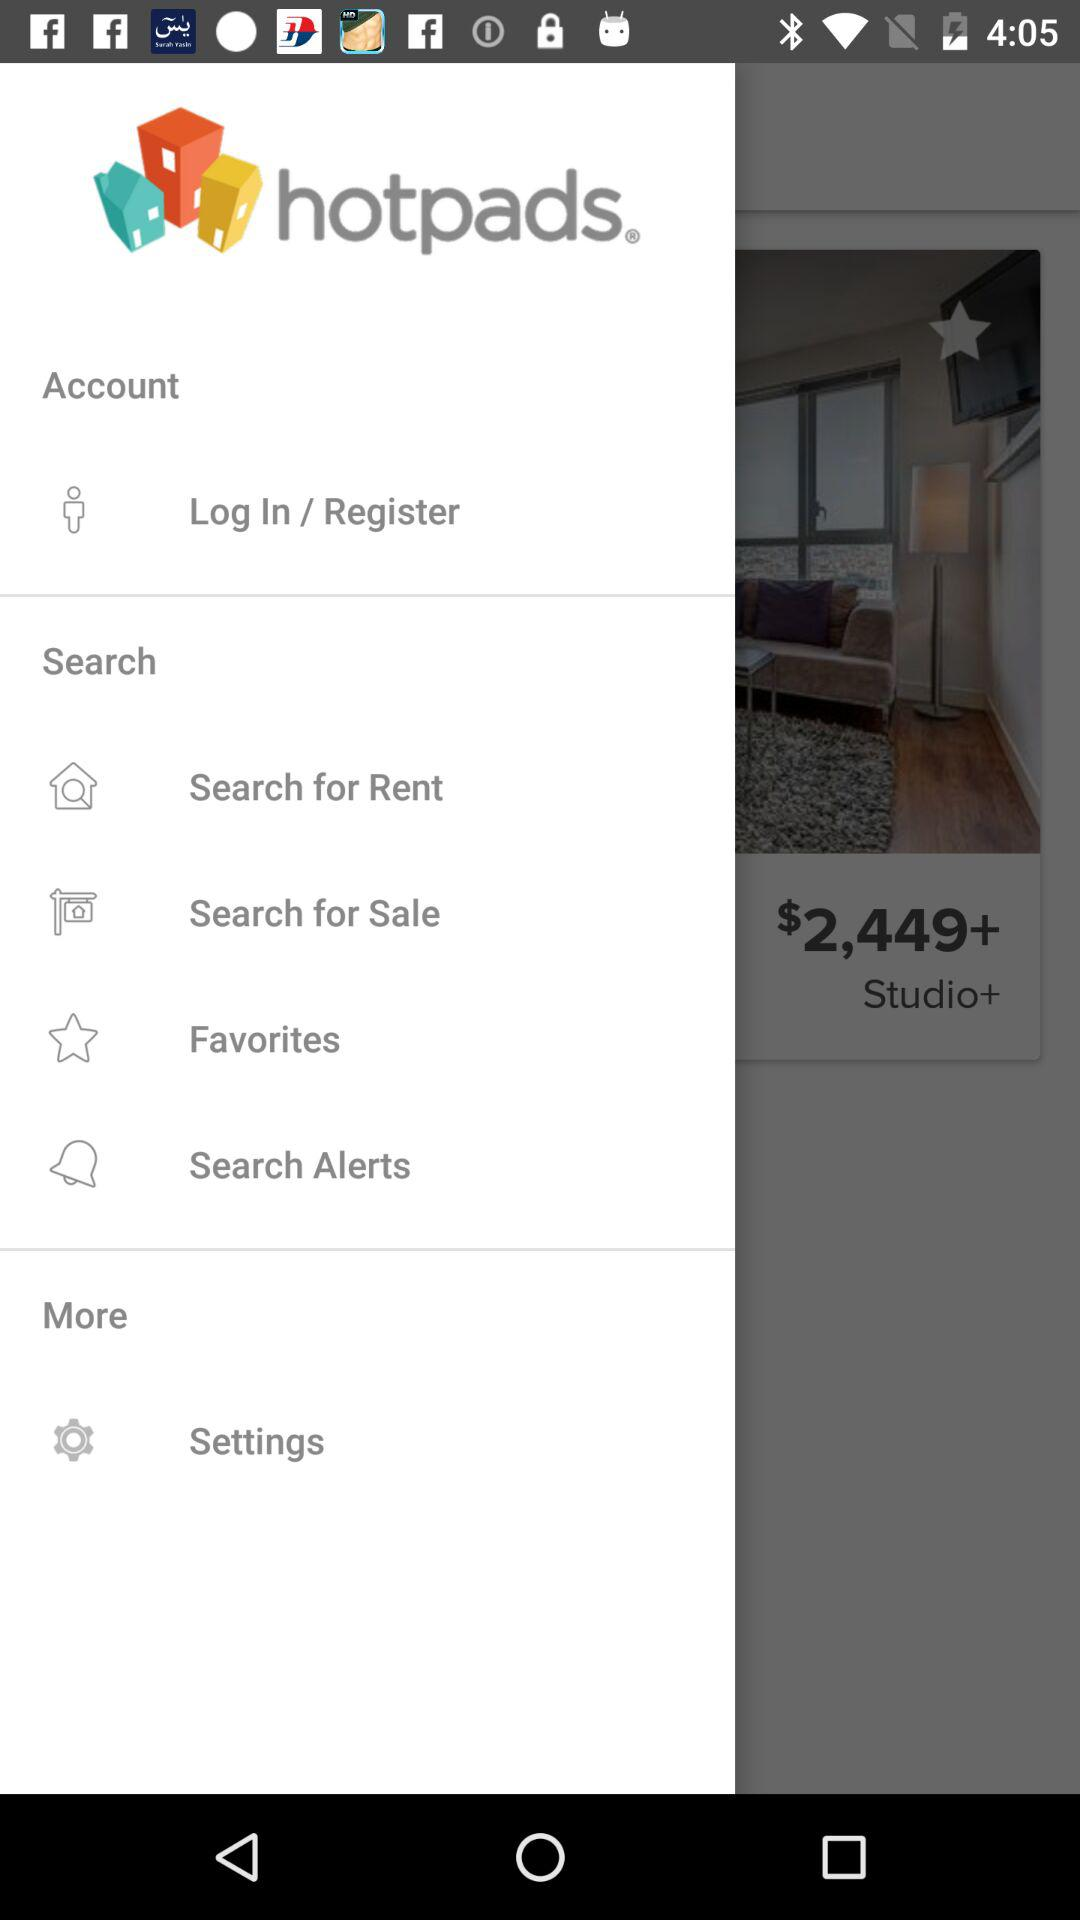What is the application name?
Answer the question using a single word or phrase. The application name is Hotpads 